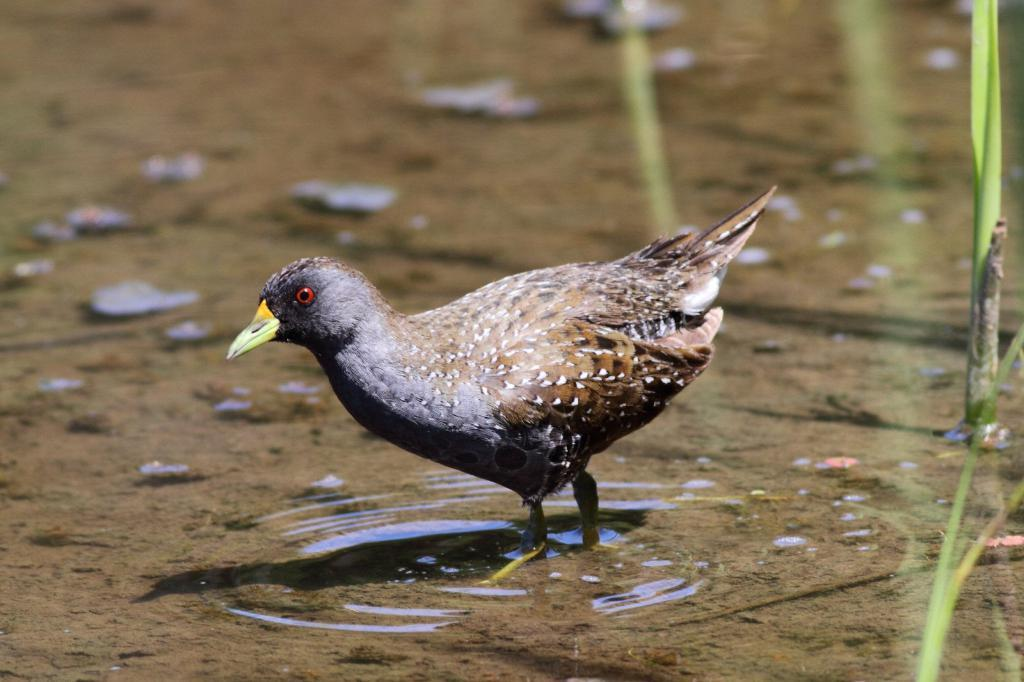What type of animal can be seen in the image? There is a bird in the image. What is located on the right side of the image? There are plants on the right side of the image. What can be seen in the background of the image? There is water visible in the background of the image. What type of father can be seen in the image? There is no father present in the image; it features a bird and plants. How many babies are visible in the image? There are no babies present in the image. 